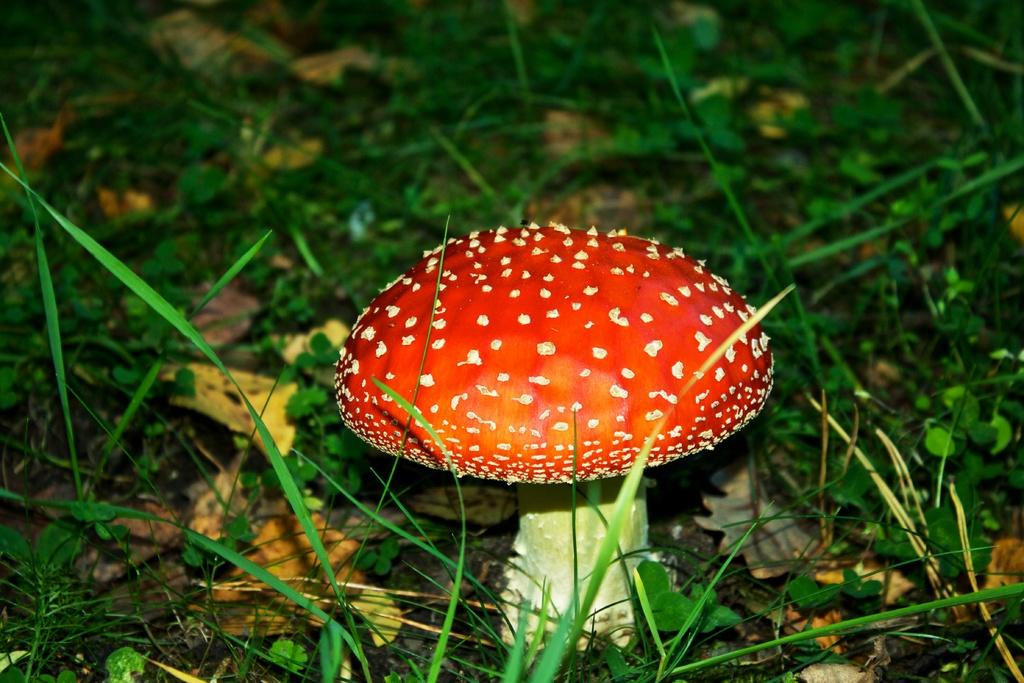What is located on the ground in the image? There is a mushroom on the ground in the image. What type of vegetation can be seen in the background of the image? There is grass visible in the background of the image. What type of fowl can be seen interacting with the mushroom in the image? There is no fowl present in the image; it only features a mushroom on the ground and grass in the background. 